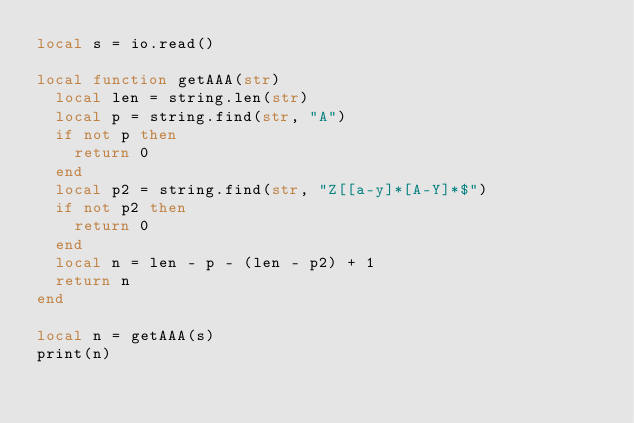Convert code to text. <code><loc_0><loc_0><loc_500><loc_500><_Lua_>local s = io.read()

local function getAAA(str)
	local len = string.len(str)
	local p = string.find(str, "A")
	if not p then
		return 0
	end
	local p2 = string.find(str, "Z[[a-y]*[A-Y]*$")
	if not p2 then
		return 0
	end
	local n = len - p - (len - p2) + 1
	return n
end

local n = getAAA(s)
print(n)</code> 